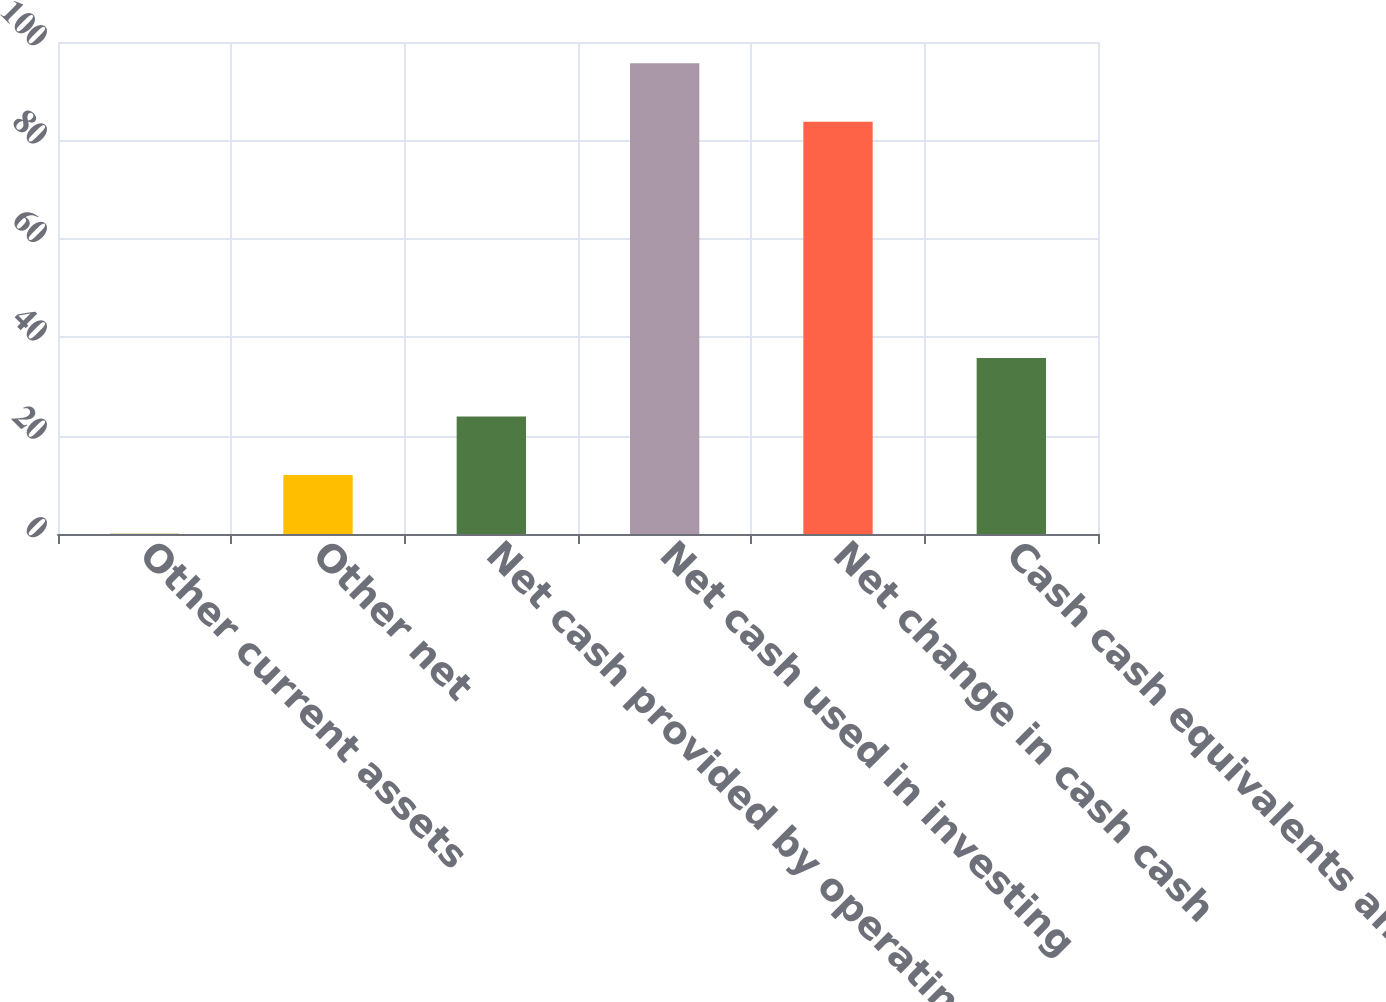Convert chart to OTSL. <chart><loc_0><loc_0><loc_500><loc_500><bar_chart><fcel>Other current assets<fcel>Other net<fcel>Net cash provided by operating<fcel>Net cash used in investing<fcel>Net change in cash cash<fcel>Cash cash equivalents and<nl><fcel>0.1<fcel>11.99<fcel>23.88<fcel>95.69<fcel>83.8<fcel>35.77<nl></chart> 